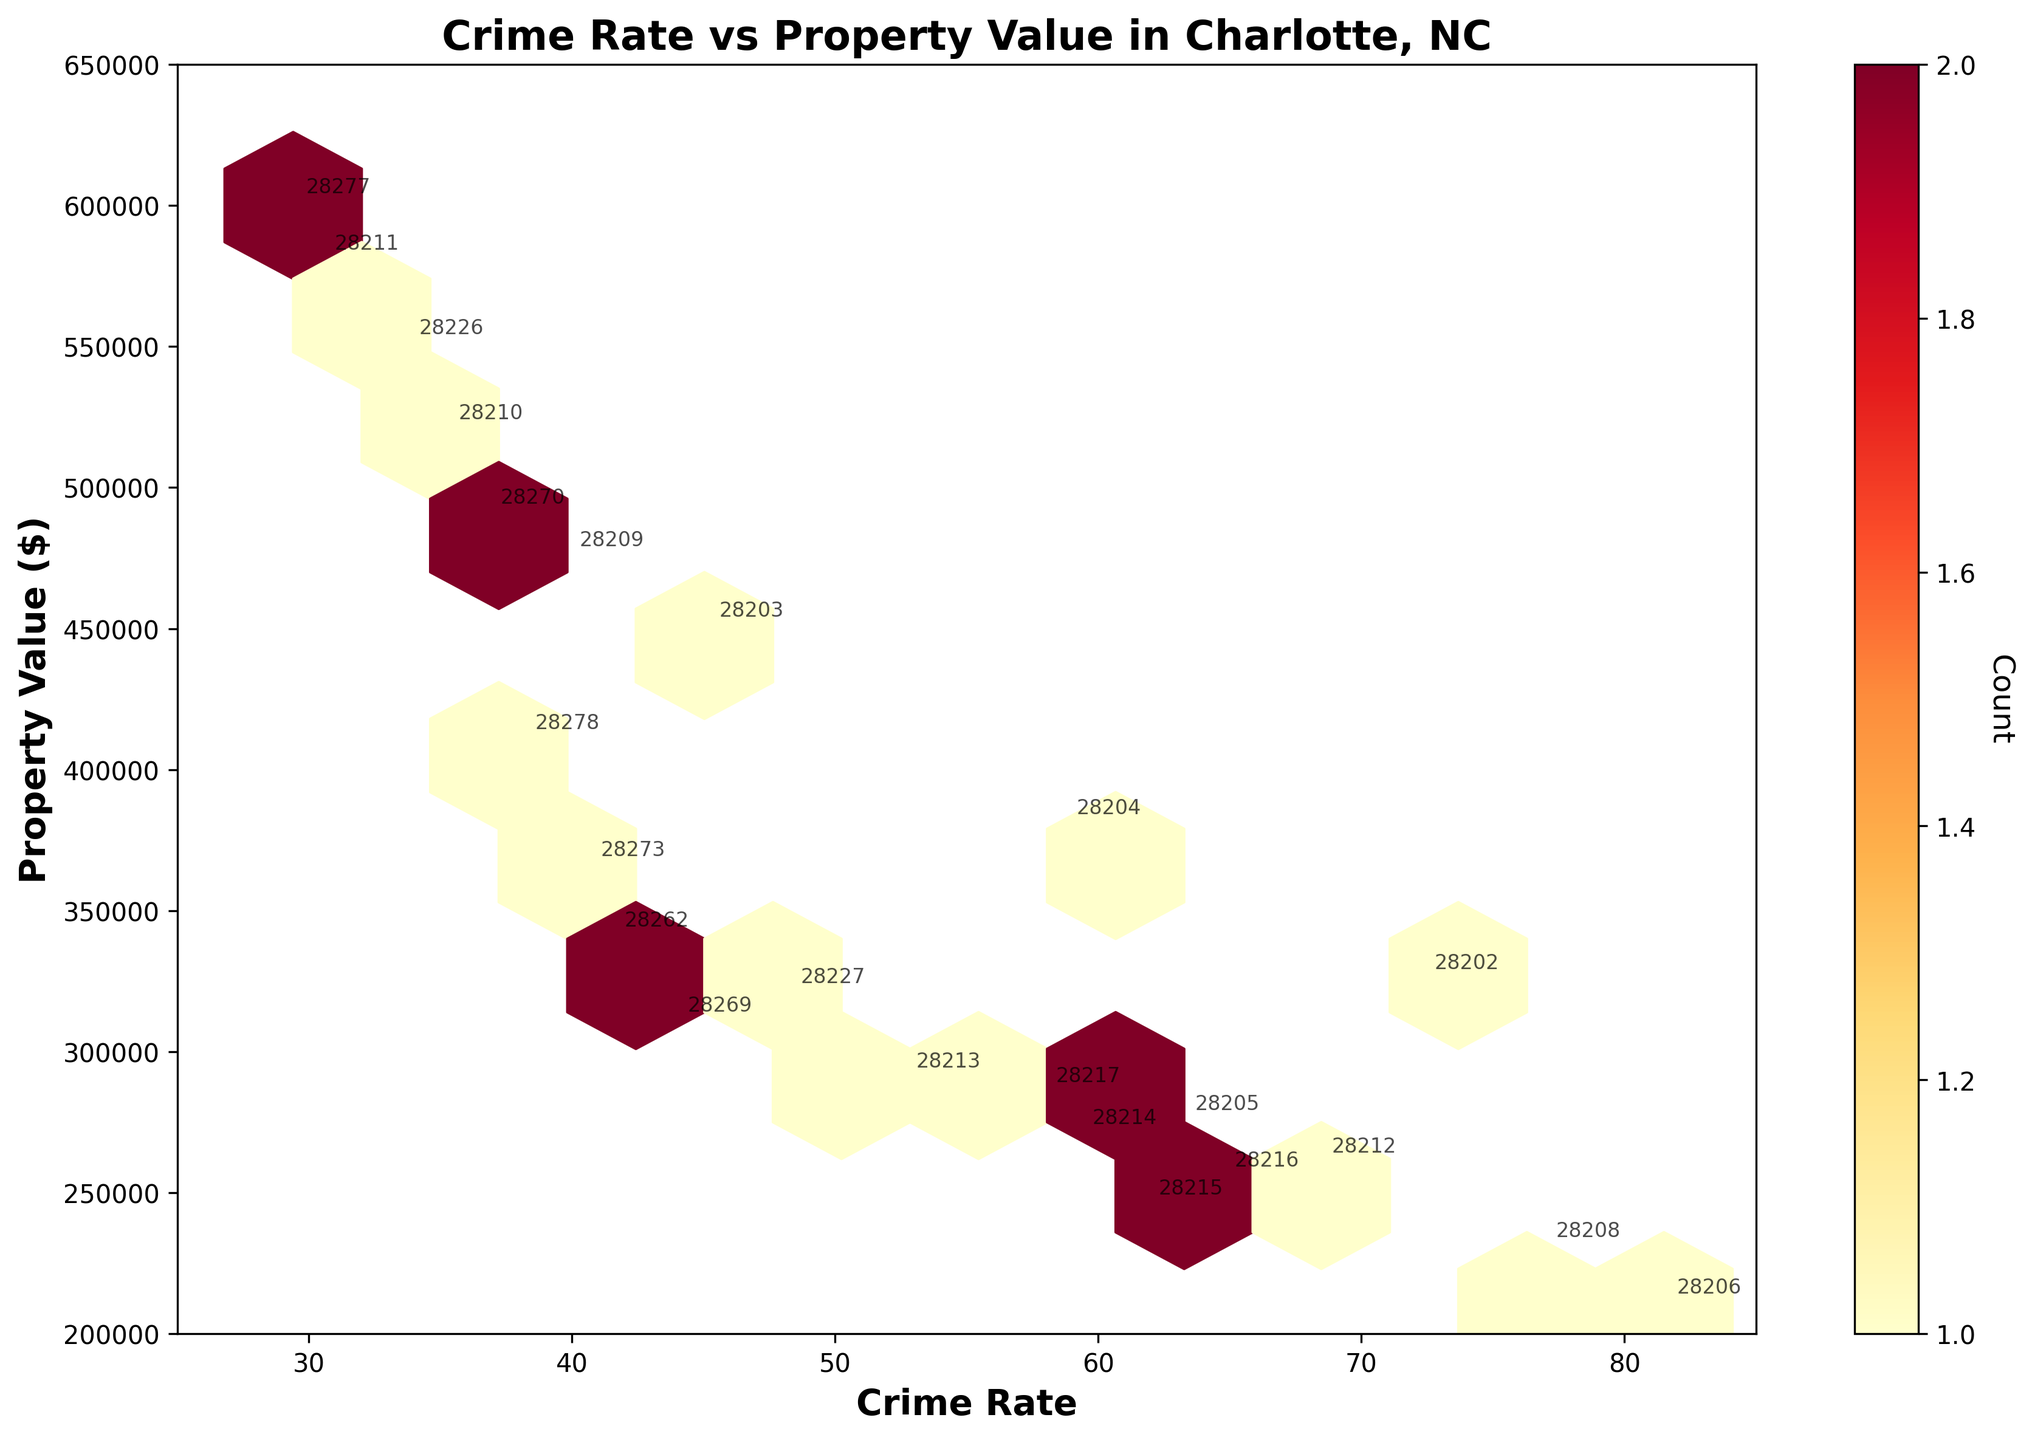What is the title of the figure? The title of the figure is displayed at the top. It reads "Crime Rate vs Property Value in Charlotte, NC."
Answer: Crime Rate vs Property Value in Charlotte, NC What are the labels on the x-axis and y-axis? The x-axis label is "Crime Rate," and the y-axis label is "Property Value ($)."
Answer: Crime Rate, Property Value ($) How many data points are in the zip code cluster with the highest crime rate? To find this, locate the hexbin with the highest crime rate value near the top of the x-axis. The color's intensity can help in determining the data density. The bins closer to 81.5 have higher crime rates. Use the color bar to determine their count.
Answer: One Which zip code has the lowest property value, and what is its crime rate? The hex with the lowest property value is near $210,000. The annotated zip code here is 28206, and the corresponding crime rate is around 81.5.
Answer: 28206, 81.5 Is there a general correlation between crime rates and property values across Charlotte zip codes? By observing the density and spread of the hexbin plot, it seems that there is an inverse correlation where higher crime rates generally correspond to lower property values.
Answer: Inverse correlation Which zip code has the highest property value, and what is its crime rate? The hex with the highest property value ($600,000) is annotated as 28277. The corresponding crime rate for this zip code is about 29.4.
Answer: 28277, 29.4 What is the median crime rate of the plotted zip codes in the hexbin plot? To find the median, list the crime rates from the dataset and find the middle value. Arranging them in ascending order: 29.4, 30.5, 33.7, 35.2, 36.8, 38.1, 39.8, 40.6, 41.5, 43.9, 45.1, 48.2, 52.6, 57.9, 58.7, 59.3, 61.8, 63.2, 64.7, 68.4, 72.3, 76.9, 81.5. The median value is the one in the middle, which is 48.2.
Answer: 48.2 Identify two zip codes with crime rates between 40 and 50 and compare their property values. Zip codes 28203 with a crime rate of 45.1 and 28262 with a crime rate of 41.5. Their property values are $450,000 and $340,000 respectively, indicating a $110,000 difference.
Answer: 28203 ($450,000), 28262 ($340,000) What is the average property value for zip codes with a crime rate above 70? Find the zip codes with crime rates above 70: 28202 ($325,000), 28206 ($210,000), and 28208 ($230,000). Average = (325,000 + 210,000 + 230,000) / 3 = 765,000 / 3 = $255,000.
Answer: $255,000 Which hexbin represents the densest concentration of data points? Identify the hexbin with the most intense color using the color bar as a guide. The densest points appear to be around $250,000-$300,000 property value and crime rates between 60 and 70.
Answer: $250,000-$300,000 property value, 60-70 crime rate 